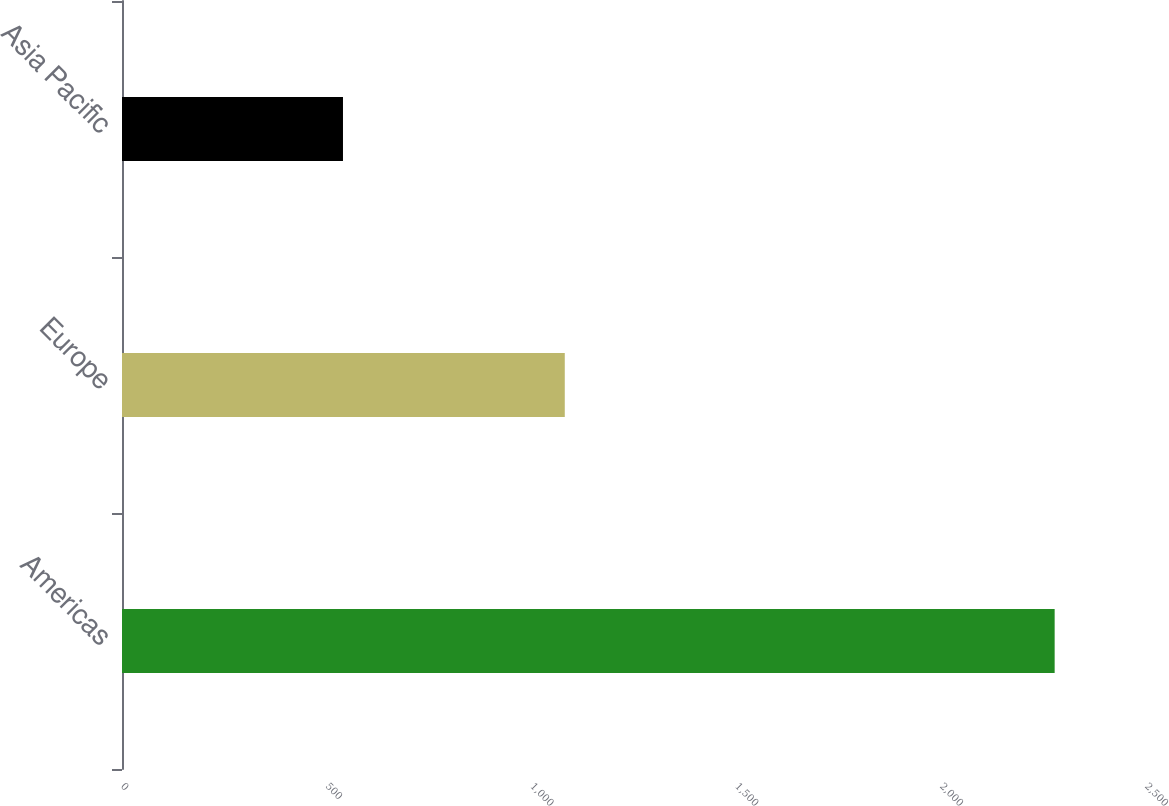<chart> <loc_0><loc_0><loc_500><loc_500><bar_chart><fcel>Americas<fcel>Europe<fcel>Asia Pacific<nl><fcel>2277<fcel>1081<fcel>539.5<nl></chart> 